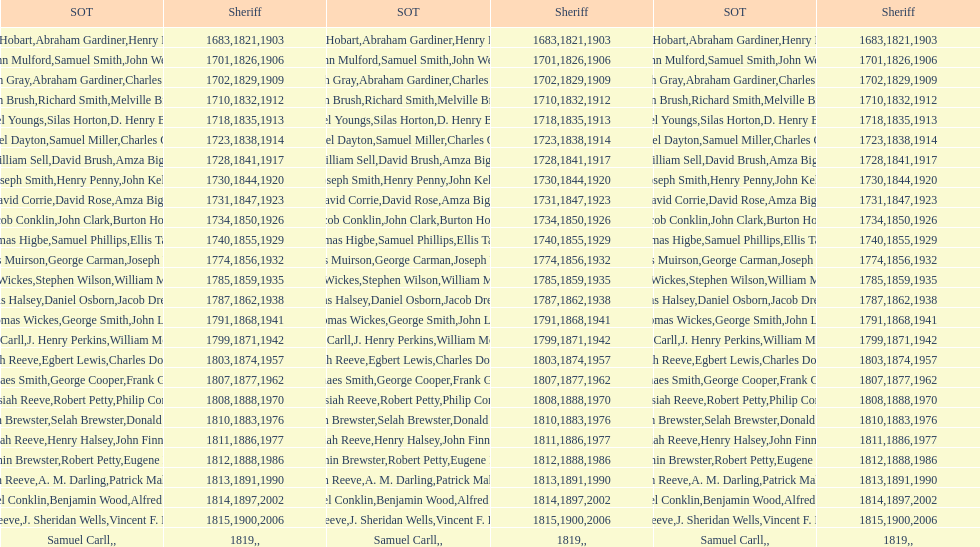How many sheriff's have the last name biggs? 1. 